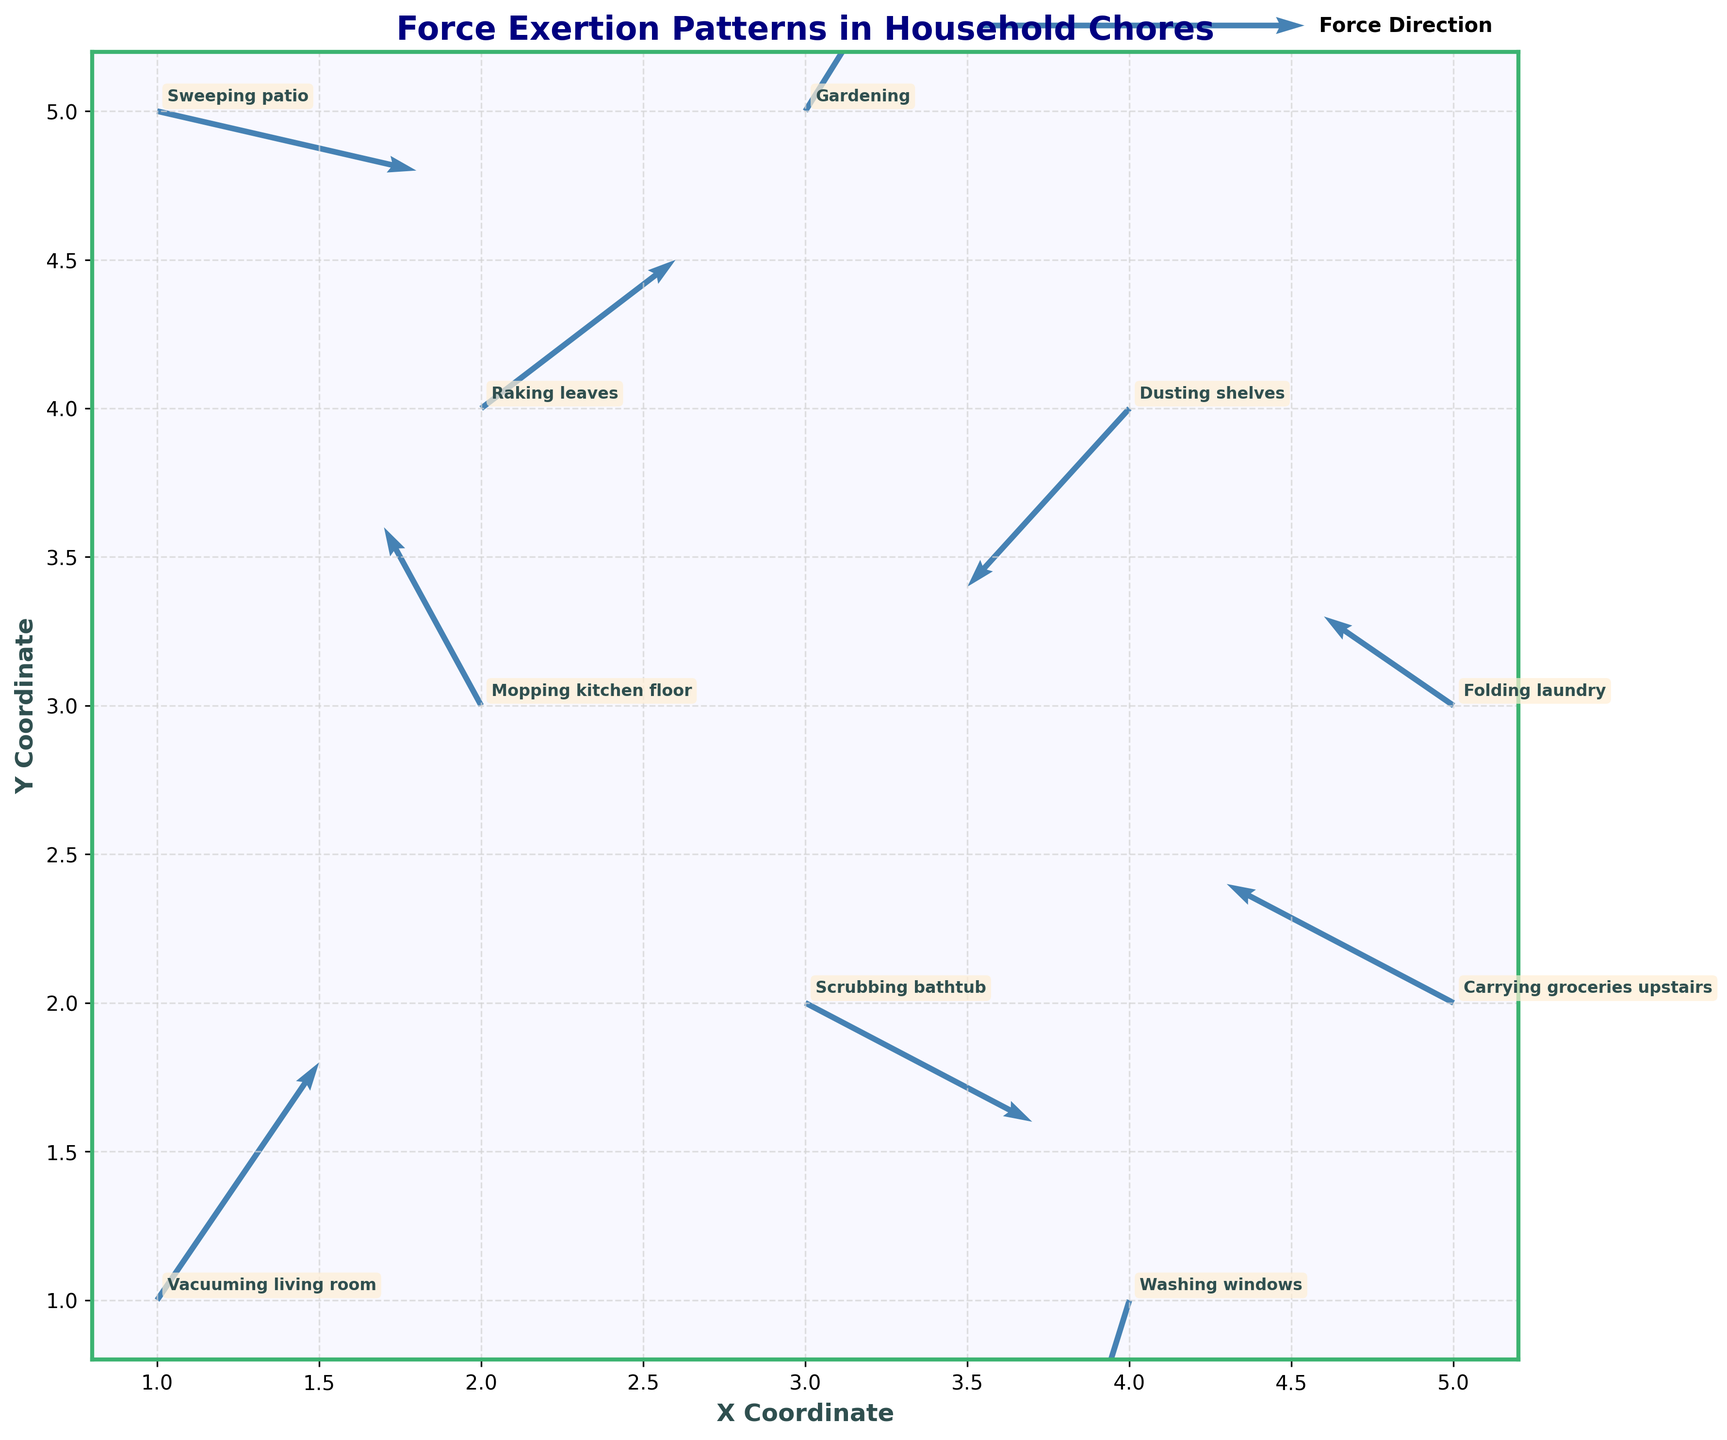What's the title of the plot? The title is typically found at the top of the plot. Here, the plot is labeled "Force Exertion Patterns in Household Chores", which is styled in bold navy text.
Answer: Force Exertion Patterns in Household Chores Which chore appears at the coordinates (3, 2)? To determine the activity at specific coordinates, look for the point labeled "Scrubbing bathtub" which is positioned at x=3 and y=2.
Answer: Scrubbing bathtub How many household chores are being analyzed in the plot? By counting the number of labeled points in the plot, we see that there are 10 different chores represented.
Answer: 10 What chore involves the greatest horizontal force? The greatest horizontal force (u-component) is indicated by the largest absolute value among the u values. "Carrying groceries upstairs" has a u value of -0.7, which is the greatest magnitude.
Answer: Carrying groceries upstairs Which activity involves the force vector pointing upward the most? Vectors pointing upward have a positive v-component. The activity with the largest positive v-component is "Vacuuming living room" with a v value of 0.8.
Answer: Vacuuming living room Compare the directional trends of "Sweeping patio" and "Dusting shelves". Which one shows a force vector with a downward component? To compare the vectors, look at their v values. "Sweeping patio" has a v of -0.2 (slightly downward), and "Dusting shelves" has a v of -0.6 (downward). Therefore, both have downward components, but "Dusting shelves" is more strongly downward.
Answer: Dusting shelves What is the sum of the horizontal components (u) for "Folding laundry" and "Mopping kitchen floor"? Adding the u values for these activities: "Folding laundry" has u = -0.4 and "Mopping kitchen floor" has u = -0.3, so the sum is -0.4 + (-0.3) = -0.7.
Answer: -0.7 Average the vertical component (v) for "Gardening" and "Raking leaves". Averaging the v values for these activities: "Gardening" has v = 0.7 and "Raking leaves" has v = 0.5. The average is (0.7 + 0.5) / 2 = 0.6.
Answer: 0.6 Which activity has a vector with a magnitude closest to 1? The magnitude of a vector (u, v) is given by sqrt(u^2 + v^2). Calculating for each activity:
"Vacuuming living room" = sqrt(0.5^2 + 0.8^2) ≈ 0.94,
"Mopping kitchen floor" = sqrt((-0.3)^2 + 0.6^2) ≈ 0.67,
"Scrubbing bathtub" = sqrt(0.7^2 + (-0.4)^2) ≈ 0.80,
"Washing windows" = sqrt((-0.2)^2 + (-0.7)^2) ≈ 0.73,
"Raking leaves" = sqrt(0.6^2 + 0.5^2) ≈ 0.78,
"Folding laundry" = sqrt((-0.4)^2 + 0.3^2) ≈ 0.50,
"Sweeping patio" = sqrt(0.8^2 + (-0.2)^2) ≈ 0.82,
"Dusting shelves" = sqrt((-0.5)^2 + (-0.6)^2) ≈ 0.78,
"Gardening" = sqrt(0.4^2 + 0.7^2) ≈ 0.80,
"Carrying groceries upstairs" = sqrt((-0.7)^2 + 0.4^2) ≈ 0.81.
"Vacuuming living room" has a magnitude closest to 1.
Answer: Vacuuming living room 